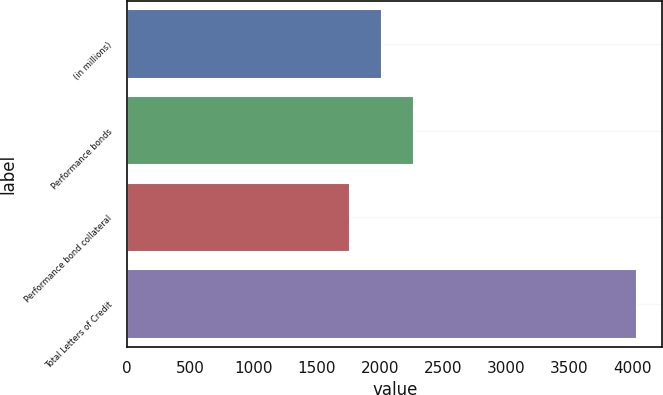<chart> <loc_0><loc_0><loc_500><loc_500><bar_chart><fcel>(in millions)<fcel>Performance bonds<fcel>Performance bond collateral<fcel>Total Letters of Credit<nl><fcel>2016<fcel>2273.7<fcel>1759.8<fcel>4033.5<nl></chart> 